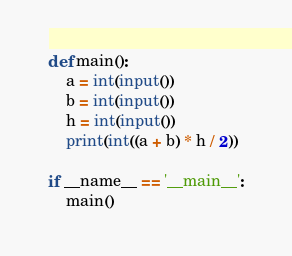Convert code to text. <code><loc_0><loc_0><loc_500><loc_500><_Python_>def main():
    a = int(input())
    b = int(input())
    h = int(input())
    print(int((a + b) * h / 2))

if __name__ == '__main__':
    main()
</code> 